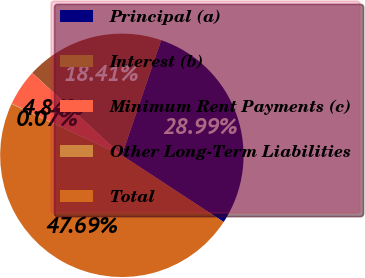Convert chart to OTSL. <chart><loc_0><loc_0><loc_500><loc_500><pie_chart><fcel>Principal (a)<fcel>Interest (b)<fcel>Minimum Rent Payments (c)<fcel>Other Long-Term Liabilities<fcel>Total<nl><fcel>28.99%<fcel>18.41%<fcel>4.84%<fcel>0.07%<fcel>47.69%<nl></chart> 